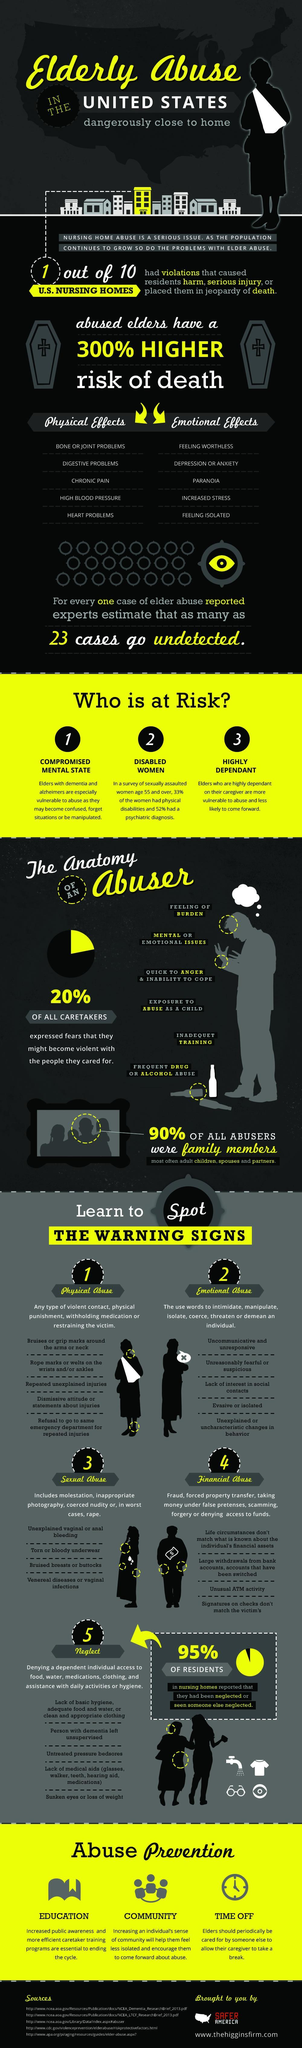which category is likely to come forward
Answer the question with a short phrase. highly dependent what sort of effect is paranoia emotional effect what sort of effect is chronic pain physical effect what was the percentage of violations in US Nursing Homes 10 what sign is unusual ATM activity financial abuse which category is at risk due to dementia and alzheimers compromised mental state how many have reported neglect 95% what sign is untreated pressure bedsores neglect how many ways are there to prevent abuse 3 